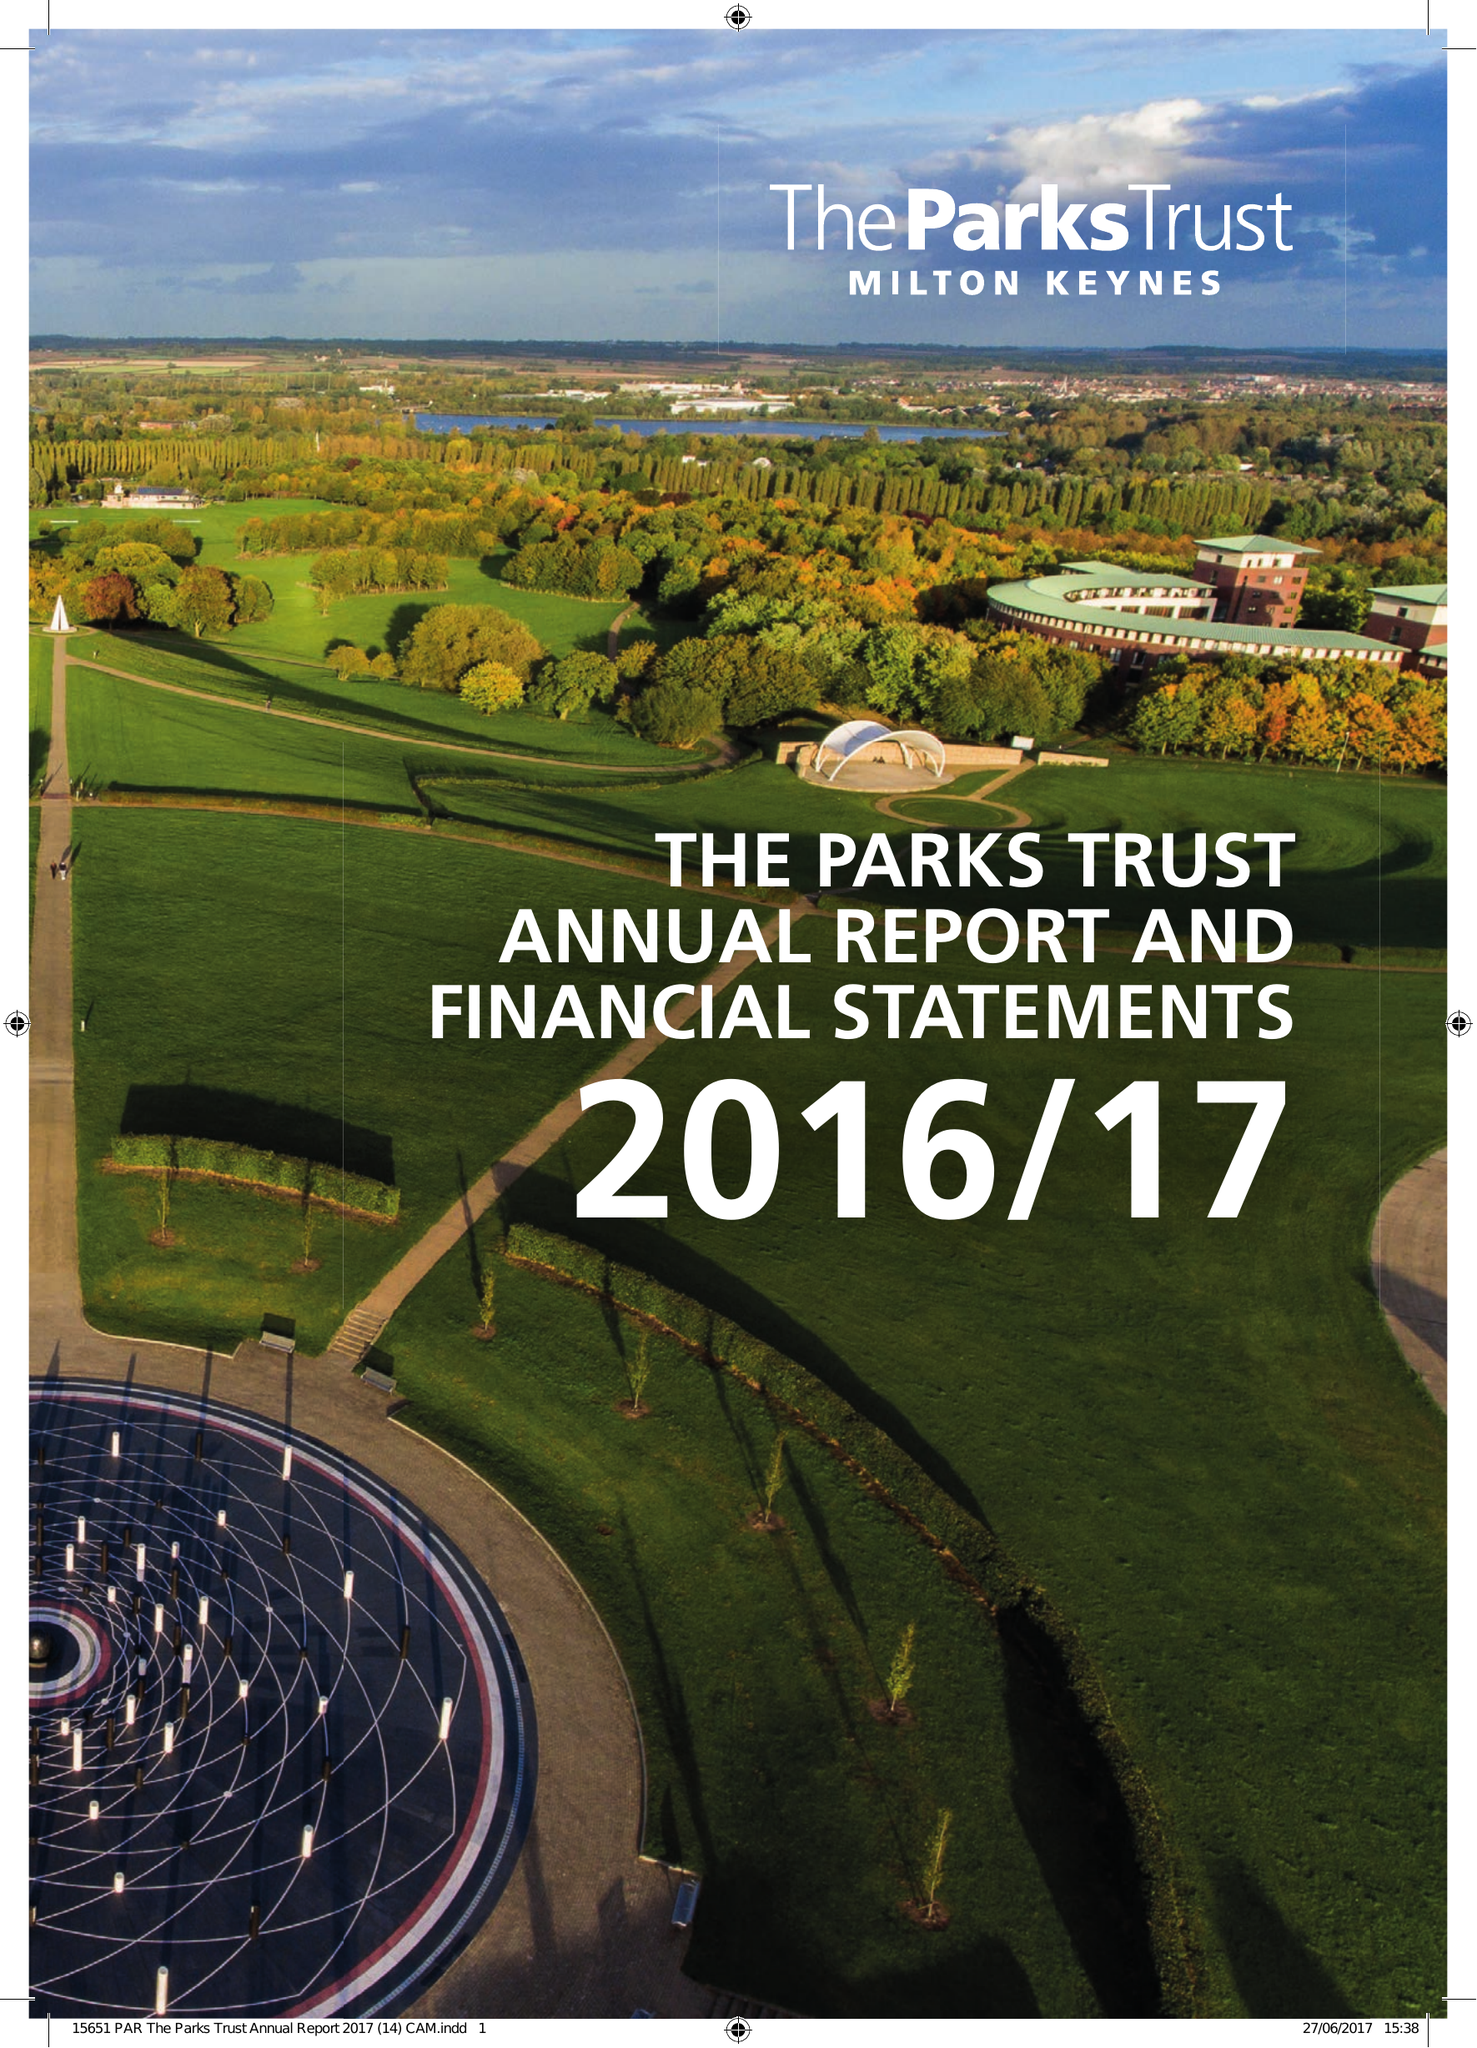What is the value for the address__postcode?
Answer the question using a single word or phrase. MK9 4AD 